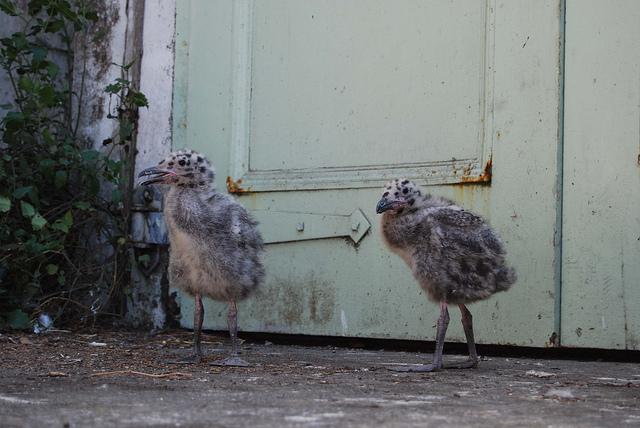Are the birds young?
Be succinct. Yes. What class of animal is this?
Concise answer only. Bird. Are the birds adults?
Write a very short answer. No. Does the birds have black spots on their heads?
Short answer required. Yes. 